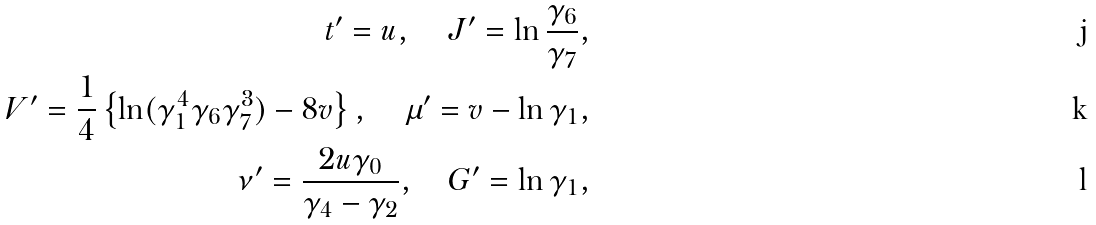<formula> <loc_0><loc_0><loc_500><loc_500>t ^ { \prime } = u , \quad J ^ { \prime } = \ln \frac { \gamma _ { 6 } } { \gamma _ { 7 } } , \\ V ^ { \prime } = \frac { 1 } { 4 } \left \{ \ln ( \gamma _ { 1 } ^ { 4 } \gamma _ { 6 } \gamma _ { 7 } ^ { 3 } ) - 8 v \right \} , \quad \mu ^ { \prime } = v - \ln \gamma _ { 1 } , \\ \nu ^ { \prime } = \frac { 2 u \gamma _ { 0 } } { \gamma _ { 4 } - \gamma _ { 2 } } , \quad G ^ { \prime } = \ln \gamma _ { 1 } ,</formula> 